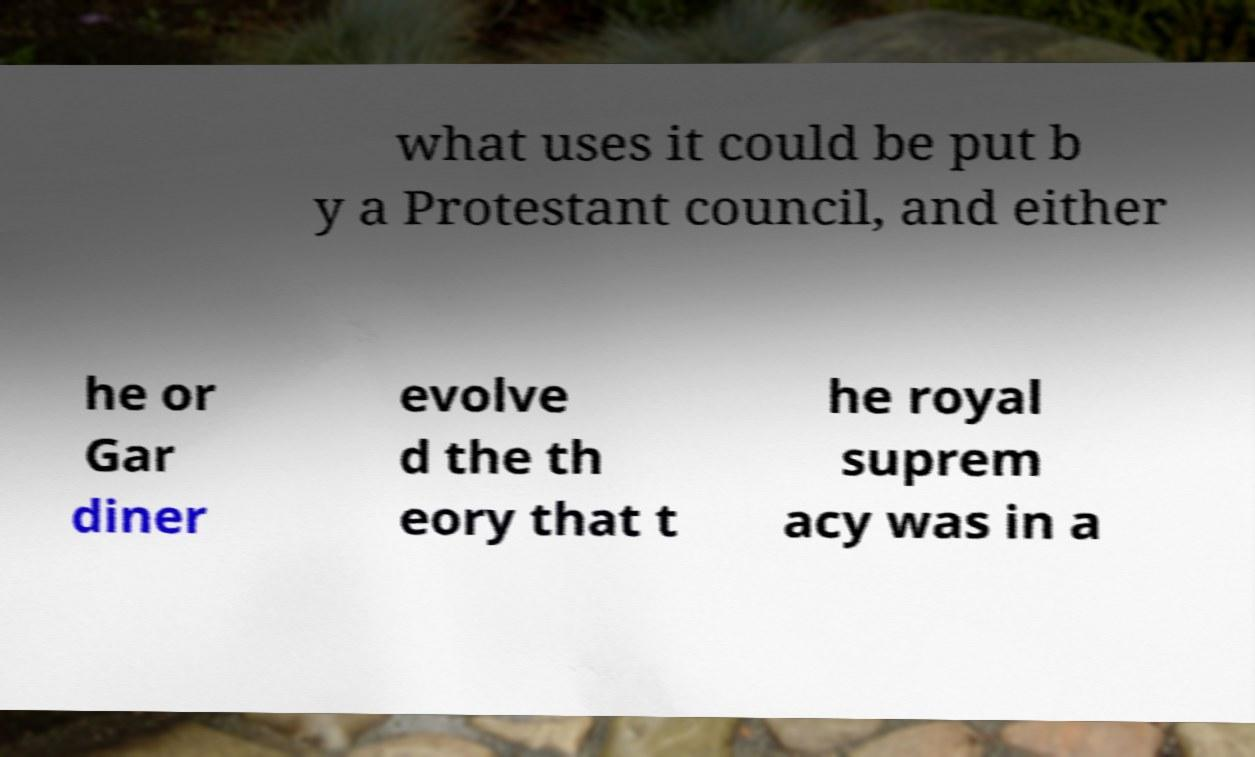Could you assist in decoding the text presented in this image and type it out clearly? what uses it could be put b y a Protestant council, and either he or Gar diner evolve d the th eory that t he royal suprem acy was in a 